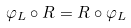Convert formula to latex. <formula><loc_0><loc_0><loc_500><loc_500>\varphi _ { L } \circ R = R \circ \varphi _ { L }</formula> 